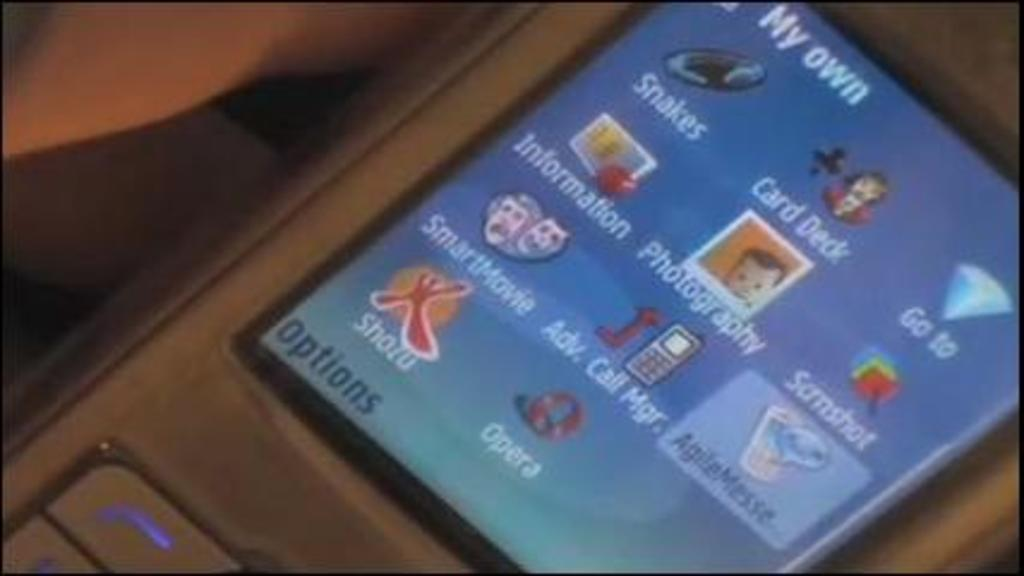<image>
Render a clear and concise summary of the photo. A device with a small screen that says my own at the top, 